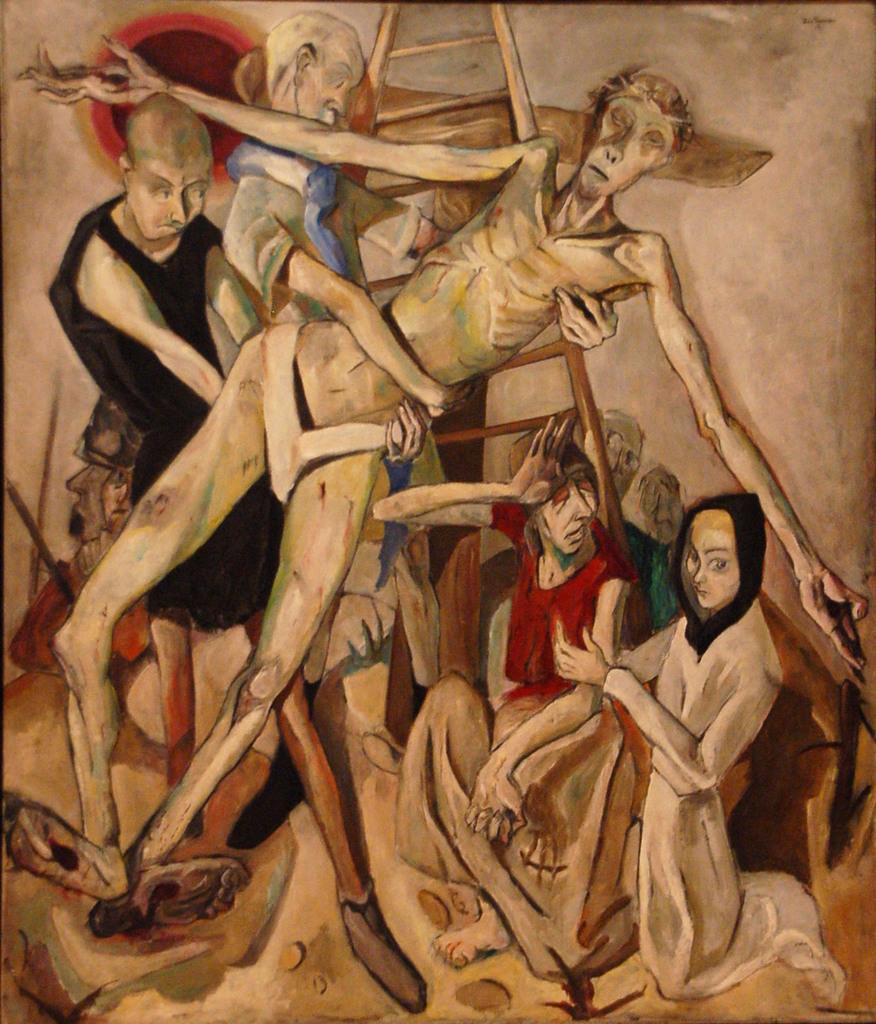What is the main subject of the image? There is a painting in the image. What is being depicted in the painting? The painting depicts people. Are there any objects or structures in the painting? Yes, there is a ladder in the painting. Can you see any cats in the painting? There are no cats present in the painting; it depicts people and a ladder. Is there any salt visible in the painting? There is no salt present in the painting; it is a depiction of people and a ladder. 